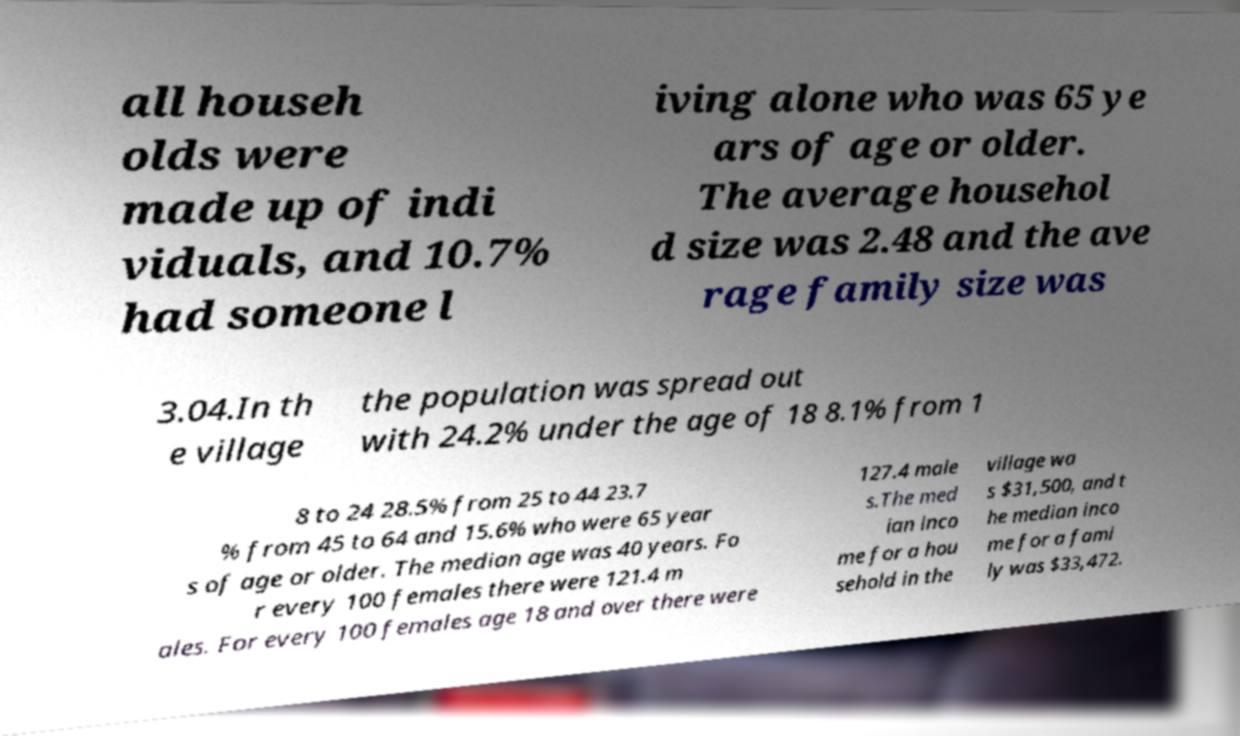Can you accurately transcribe the text from the provided image for me? all househ olds were made up of indi viduals, and 10.7% had someone l iving alone who was 65 ye ars of age or older. The average househol d size was 2.48 and the ave rage family size was 3.04.In th e village the population was spread out with 24.2% under the age of 18 8.1% from 1 8 to 24 28.5% from 25 to 44 23.7 % from 45 to 64 and 15.6% who were 65 year s of age or older. The median age was 40 years. Fo r every 100 females there were 121.4 m ales. For every 100 females age 18 and over there were 127.4 male s.The med ian inco me for a hou sehold in the village wa s $31,500, and t he median inco me for a fami ly was $33,472. 